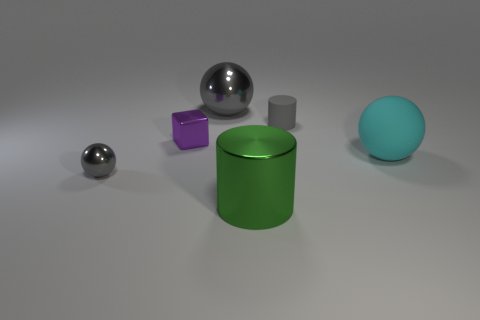Subtract all cylinders. How many objects are left? 4 Subtract 1 cubes. How many cubes are left? 0 Subtract all cyan balls. Subtract all yellow cylinders. How many balls are left? 2 Subtract all gray cubes. How many cyan balls are left? 1 Subtract all tiny shiny cubes. Subtract all small yellow metal spheres. How many objects are left? 5 Add 4 purple shiny blocks. How many purple shiny blocks are left? 5 Add 5 large green cylinders. How many large green cylinders exist? 6 Add 3 big yellow matte balls. How many objects exist? 9 Subtract all gray balls. How many balls are left? 1 Subtract all small shiny spheres. How many spheres are left? 2 